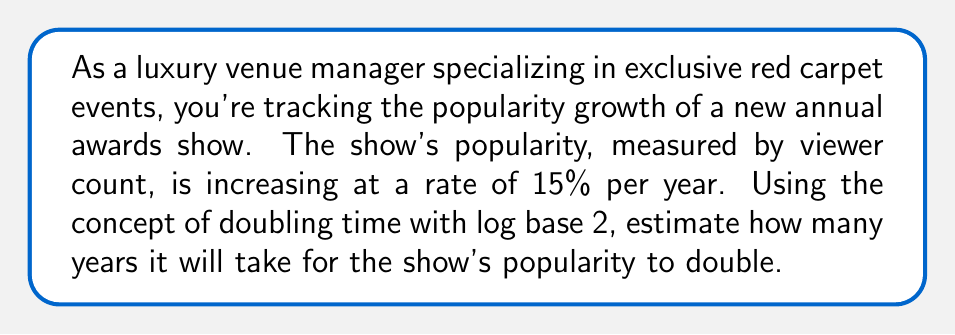Solve this math problem. To solve this problem, we'll use the concept of doubling time and the properties of logarithms.

1) The general formula for doubling time is:

   $$T = \frac{\log 2}{\log (1 + r)}$$

   Where $T$ is the time to double, and $r$ is the growth rate as a decimal.

2) In this case, $r = 0.15$ (15% converted to decimal)

3) We're using log base 2, so we need to convert the formula:

   $$T = \frac{\log_2 2}{\log_2 (1 + r)}$$

4) Simplify $\log_2 2 = 1$:

   $$T = \frac{1}{\log_2 (1 + r)}$$

5) Substitute $r = 0.15$:

   $$T = \frac{1}{\log_2 (1 + 0.15)} = \frac{1}{\log_2 (1.15)}$$

6) Calculate:

   $$T = \frac{1}{\log_2 (1.15)} \approx 4.96$$

7) Round to the nearest whole number, as we're dealing with years:

   $$T \approx 5 \text{ years}$$
Answer: It will take approximately 5 years for the awards show's popularity to double. 